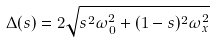Convert formula to latex. <formula><loc_0><loc_0><loc_500><loc_500>\Delta ( s ) = 2 \sqrt { s ^ { 2 } \omega _ { 0 } ^ { 2 } + ( 1 - s ) ^ { 2 } \omega _ { x } ^ { 2 } }</formula> 